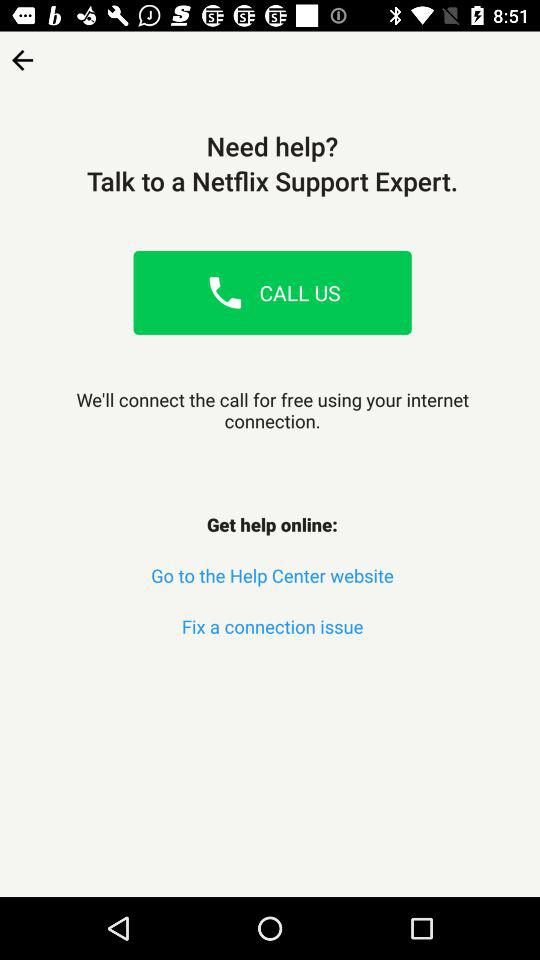How many ways can I get help with Netflix?
Answer the question using a single word or phrase. 2 